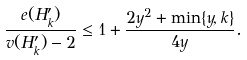<formula> <loc_0><loc_0><loc_500><loc_500>\frac { e ( H _ { k } ^ { \prime } ) } { v ( H _ { k } ^ { \prime } ) - 2 } \leq 1 + \frac { 2 y ^ { 2 } + \min \{ y , k \} } { 4 y } .</formula> 